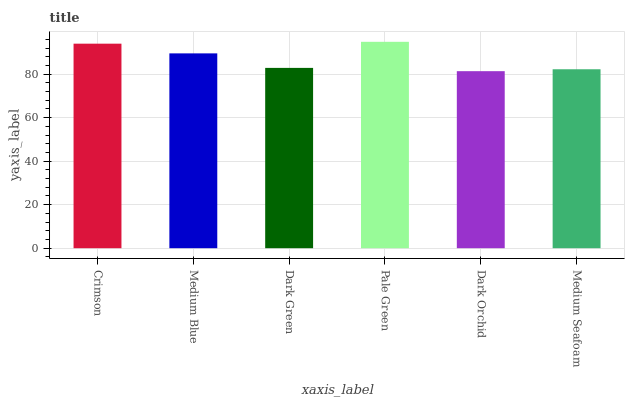Is Dark Orchid the minimum?
Answer yes or no. Yes. Is Pale Green the maximum?
Answer yes or no. Yes. Is Medium Blue the minimum?
Answer yes or no. No. Is Medium Blue the maximum?
Answer yes or no. No. Is Crimson greater than Medium Blue?
Answer yes or no. Yes. Is Medium Blue less than Crimson?
Answer yes or no. Yes. Is Medium Blue greater than Crimson?
Answer yes or no. No. Is Crimson less than Medium Blue?
Answer yes or no. No. Is Medium Blue the high median?
Answer yes or no. Yes. Is Dark Green the low median?
Answer yes or no. Yes. Is Dark Green the high median?
Answer yes or no. No. Is Medium Blue the low median?
Answer yes or no. No. 